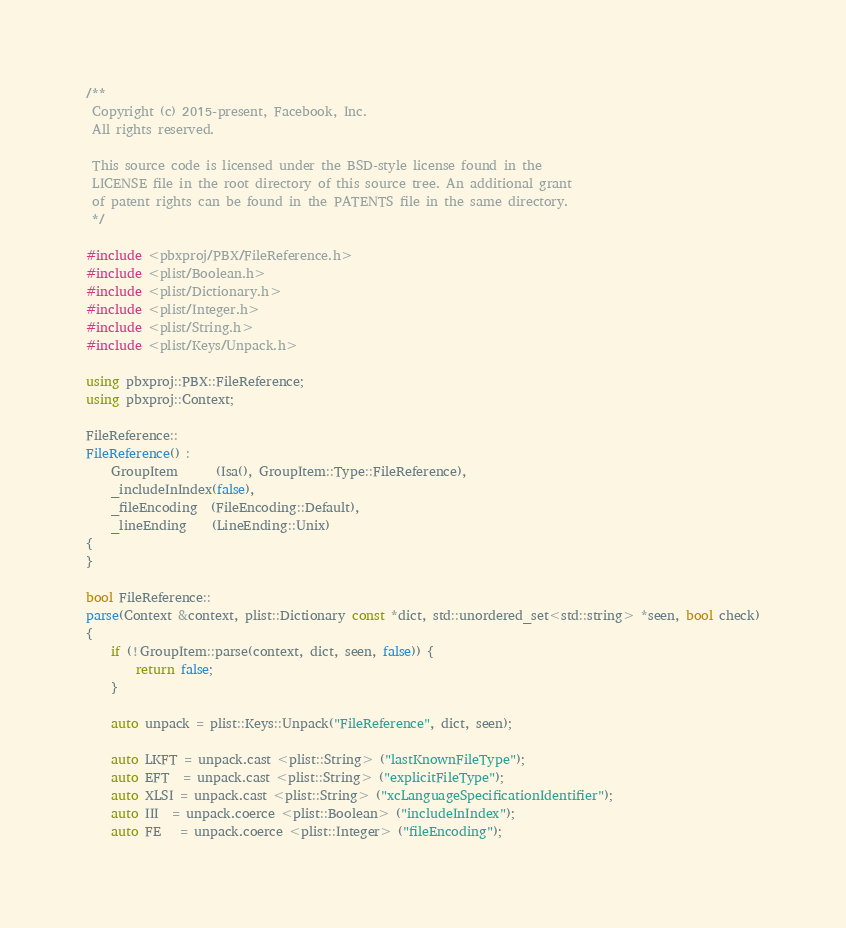Convert code to text. <code><loc_0><loc_0><loc_500><loc_500><_C++_>/**
 Copyright (c) 2015-present, Facebook, Inc.
 All rights reserved.

 This source code is licensed under the BSD-style license found in the
 LICENSE file in the root directory of this source tree. An additional grant
 of patent rights can be found in the PATENTS file in the same directory.
 */

#include <pbxproj/PBX/FileReference.h>
#include <plist/Boolean.h>
#include <plist/Dictionary.h>
#include <plist/Integer.h>
#include <plist/String.h>
#include <plist/Keys/Unpack.h>

using pbxproj::PBX::FileReference;
using pbxproj::Context;

FileReference::
FileReference() :
    GroupItem      (Isa(), GroupItem::Type::FileReference),
    _includeInIndex(false),
    _fileEncoding  (FileEncoding::Default),
    _lineEnding    (LineEnding::Unix)
{
}

bool FileReference::
parse(Context &context, plist::Dictionary const *dict, std::unordered_set<std::string> *seen, bool check)
{
    if (!GroupItem::parse(context, dict, seen, false)) {
        return false;
    }

    auto unpack = plist::Keys::Unpack("FileReference", dict, seen);

    auto LKFT = unpack.cast <plist::String> ("lastKnownFileType");
    auto EFT  = unpack.cast <plist::String> ("explicitFileType");
    auto XLSI = unpack.cast <plist::String> ("xcLanguageSpecificationIdentifier");
    auto III  = unpack.coerce <plist::Boolean> ("includeInIndex");
    auto FE   = unpack.coerce <plist::Integer> ("fileEncoding");</code> 